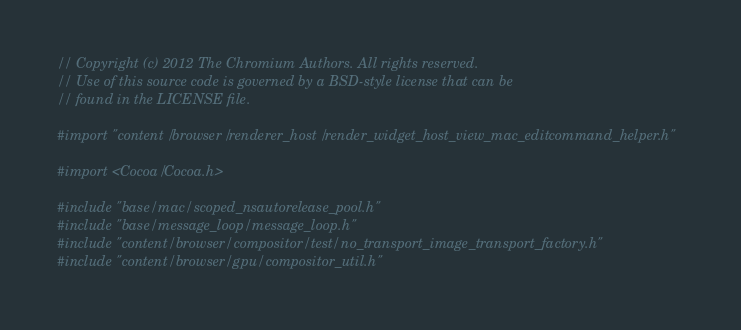<code> <loc_0><loc_0><loc_500><loc_500><_ObjectiveC_>// Copyright (c) 2012 The Chromium Authors. All rights reserved.
// Use of this source code is governed by a BSD-style license that can be
// found in the LICENSE file.

#import "content/browser/renderer_host/render_widget_host_view_mac_editcommand_helper.h"

#import <Cocoa/Cocoa.h>

#include "base/mac/scoped_nsautorelease_pool.h"
#include "base/message_loop/message_loop.h"
#include "content/browser/compositor/test/no_transport_image_transport_factory.h"
#include "content/browser/gpu/compositor_util.h"</code> 